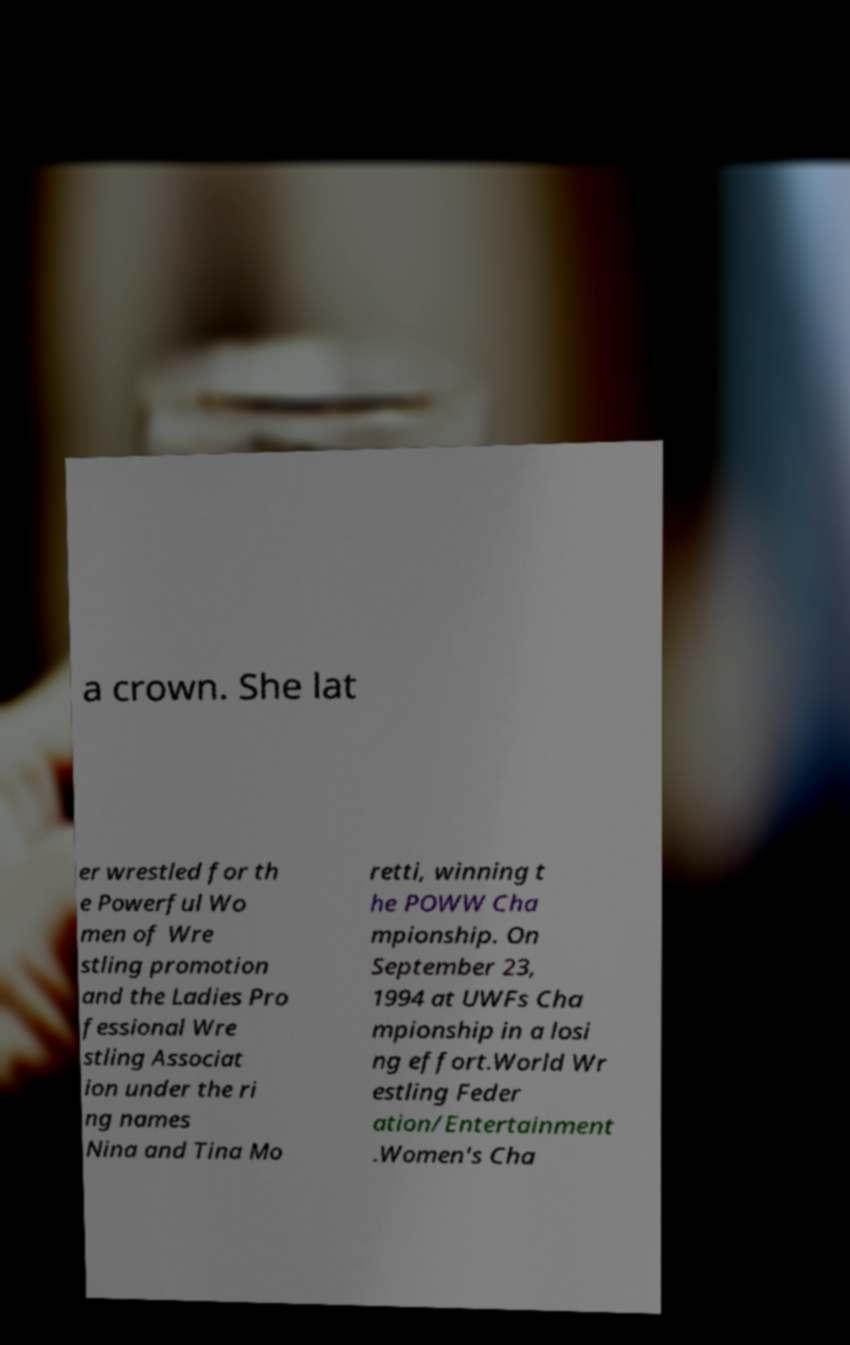There's text embedded in this image that I need extracted. Can you transcribe it verbatim? a crown. She lat er wrestled for th e Powerful Wo men of Wre stling promotion and the Ladies Pro fessional Wre stling Associat ion under the ri ng names Nina and Tina Mo retti, winning t he POWW Cha mpionship. On September 23, 1994 at UWFs Cha mpionship in a losi ng effort.World Wr estling Feder ation/Entertainment .Women's Cha 